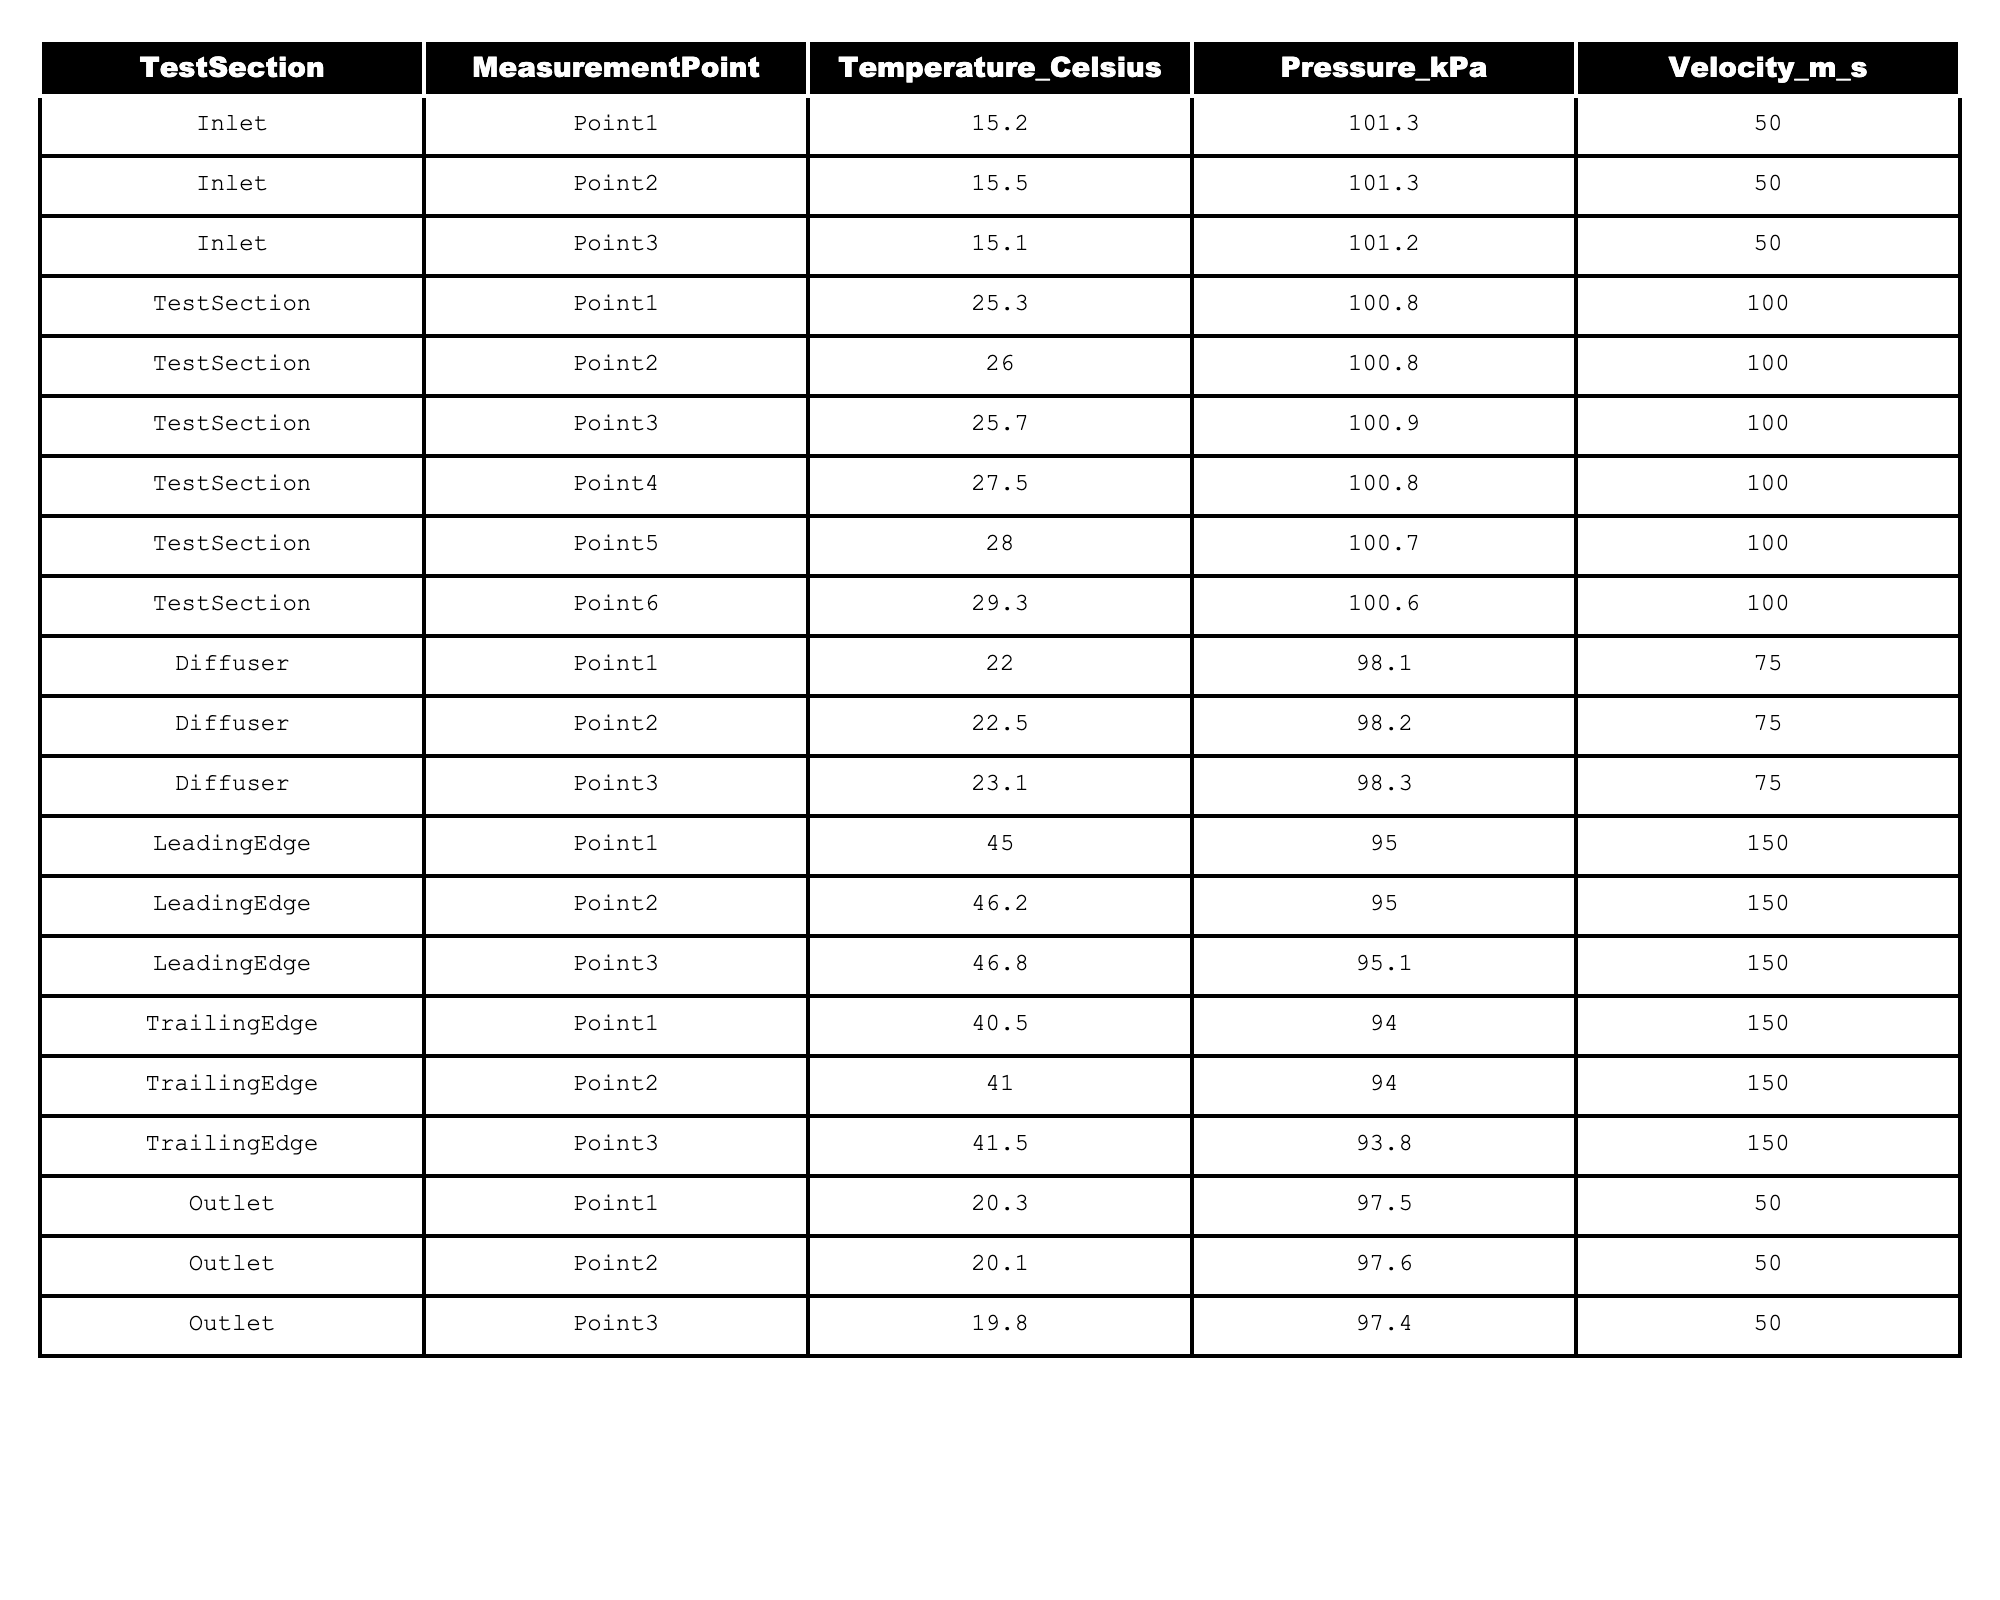What is the temperature measured at Point 3 in the Test Section? Referring to the table, the temperature at Point 3 in the Test Section is listed as 25.7 degrees Celsius.
Answer: 25.7 What is the pressure at the Inlet measurement points? All Inlet measurement points have a pressure of 101.3 kPa, except Point 3 which has 101.2 kPa.
Answer: 101.3 kPa (except for Point 3: 101.2 kPa) What is the average temperature at the Trailing Edge measurement points? The temperatures at the Trailing Edge points are 40.5, 41.0, and 41.5 degrees Celsius. The average is (40.5 + 41.0 + 41.5) / 3 = 41.0 degrees Celsius.
Answer: 41.0 Is the temperature at the Leading Edge higher than at the Diffuser? The maximum temperature at the Leading Edge is 46.8 degrees Celsius and at the Diffuser the highest is 23.1 degrees Celsius. Since 46.8 > 23.1, the statement is true.
Answer: Yes What is the difference in temperature between the maximum at the Test Section and the minimum at the Outlet? The maximum temperature at the Test Section is 29.3 degrees Celsius, and the minimum temperature at the Outlet is 19.8 degrees Celsius. The difference is 29.3 - 19.8 = 9.5 degrees Celsius.
Answer: 9.5 What temperature point exceeds 40 degrees Celsius and is measured at the Leading Edge? The temperature points at the Leading Edge are 45.0, 46.2, and 46.8 degrees Celsius, all of which exceed 40 degrees Celsius.
Answer: True How do the average temperatures at the Inlet and Outlet compare? The average temperature at the Inlet is (15.2 + 15.5 + 15.1) / 3 = 15.27 degrees Celsius, while at the Outlet it is (20.3 + 20.1 + 19.8) / 3 = 20.07 degrees Celsius. Since 20.07 > 15.27, the Outlet is warmer.
Answer: Outlet is warmer What is the total pressure at the Inlet measurement points? The pressures at the Inlet are 101.3 kPa (twice) and 101.2 kPa, summing them gives 101.3 + 101.3 + 101.2 = 303.8 kPa.
Answer: 303.8 kPa Which measurement points have a temperature above 25 degrees Celsius? Points in the Test Section are all above 25 degrees Celsius, specifically Points 4, 5, and 6 with temperatures of 27.5, 28.0, and 29.3.
Answer: Points 4, 5, 6 in Test Section How does the velocity at the Leading Edge compare to that in the Diffuser? The velocity at the Leading Edge is 150 m/s, while in the Diffuser it is 75 m/s. Since 150 > 75, the Leading Edge has a higher velocity.
Answer: Leading Edge is higher 